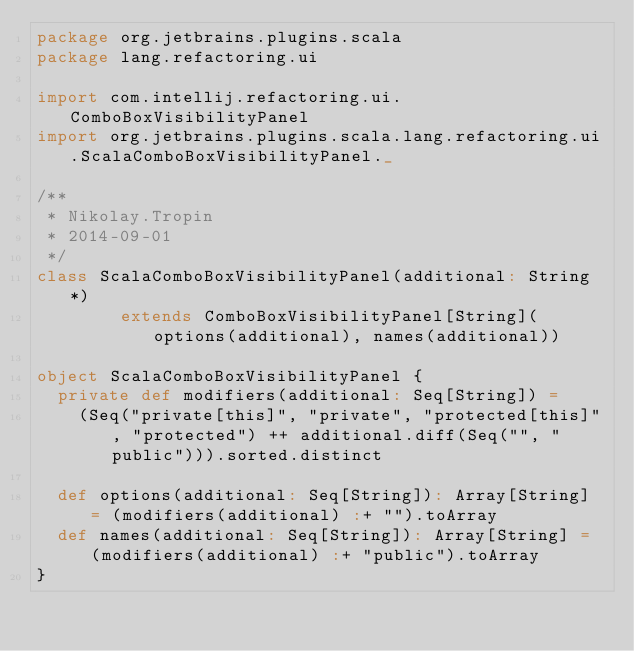<code> <loc_0><loc_0><loc_500><loc_500><_Scala_>package org.jetbrains.plugins.scala
package lang.refactoring.ui

import com.intellij.refactoring.ui.ComboBoxVisibilityPanel
import org.jetbrains.plugins.scala.lang.refactoring.ui.ScalaComboBoxVisibilityPanel._

/**
 * Nikolay.Tropin
 * 2014-09-01
 */
class ScalaComboBoxVisibilityPanel(additional: String*)
        extends ComboBoxVisibilityPanel[String](options(additional), names(additional))

object ScalaComboBoxVisibilityPanel {
  private def modifiers(additional: Seq[String]) =
    (Seq("private[this]", "private", "protected[this]", "protected") ++ additional.diff(Seq("", "public"))).sorted.distinct

  def options(additional: Seq[String]): Array[String] = (modifiers(additional) :+ "").toArray
  def names(additional: Seq[String]): Array[String] = (modifiers(additional) :+ "public").toArray
}
</code> 